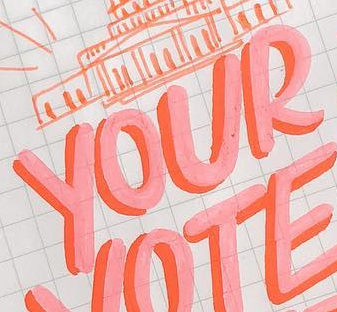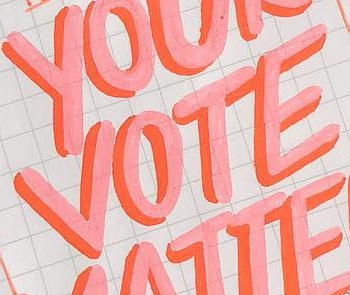What words are shown in these images in order, separated by a semicolon? YOUR; VOTE 